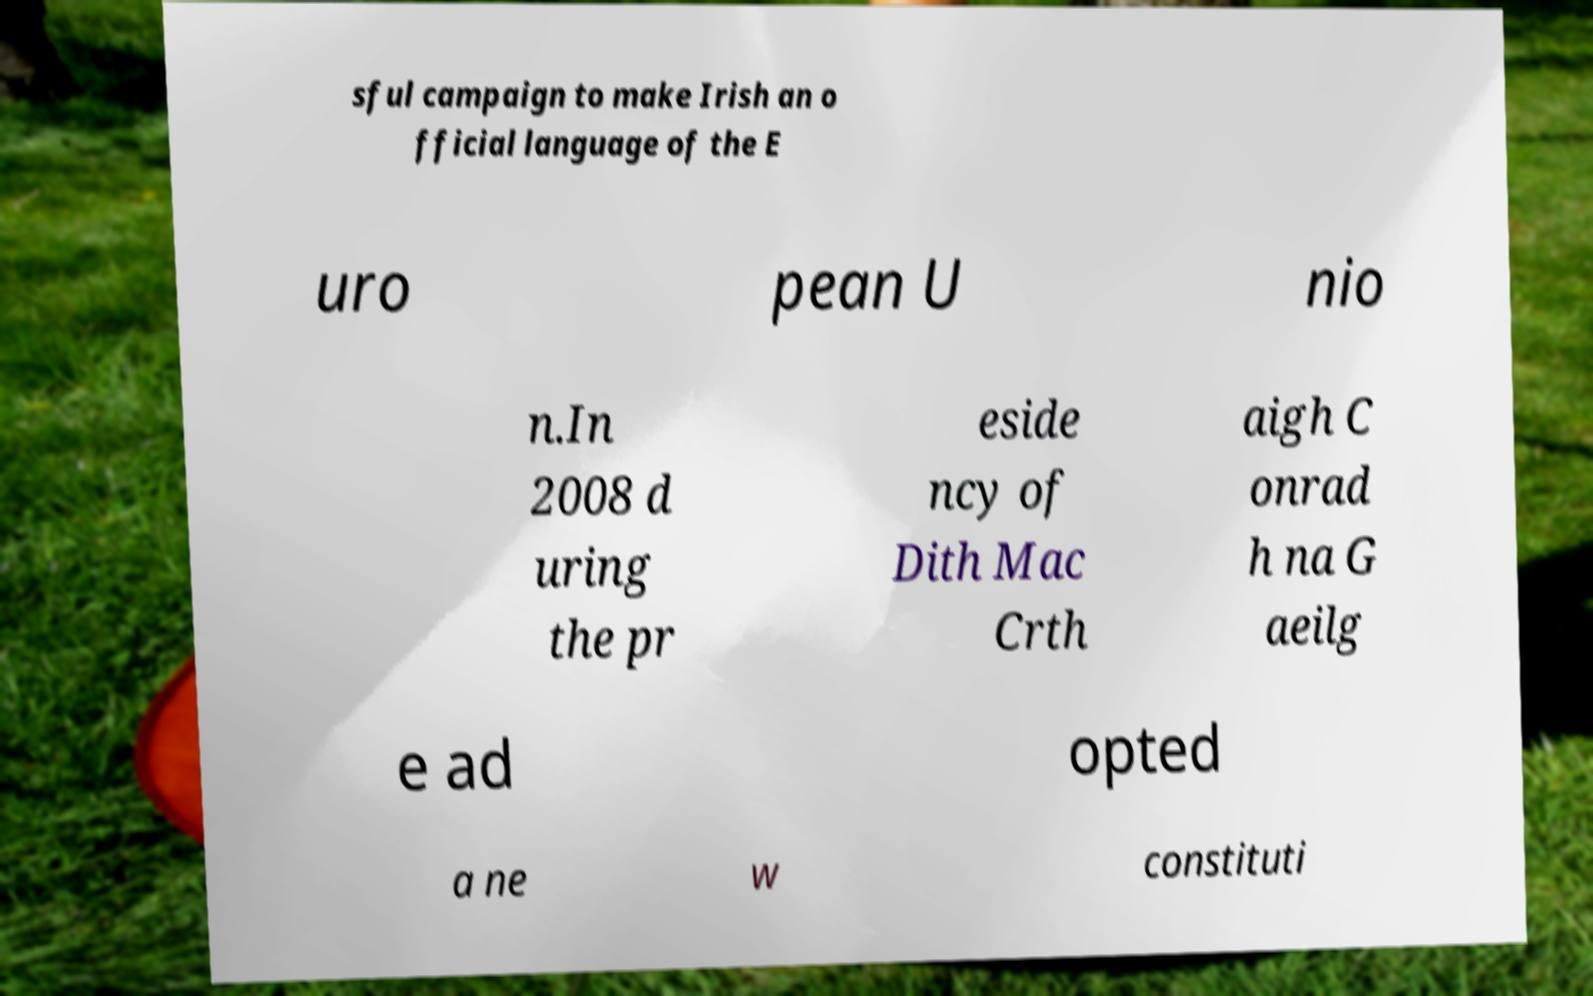Please read and relay the text visible in this image. What does it say? sful campaign to make Irish an o fficial language of the E uro pean U nio n.In 2008 d uring the pr eside ncy of Dith Mac Crth aigh C onrad h na G aeilg e ad opted a ne w constituti 